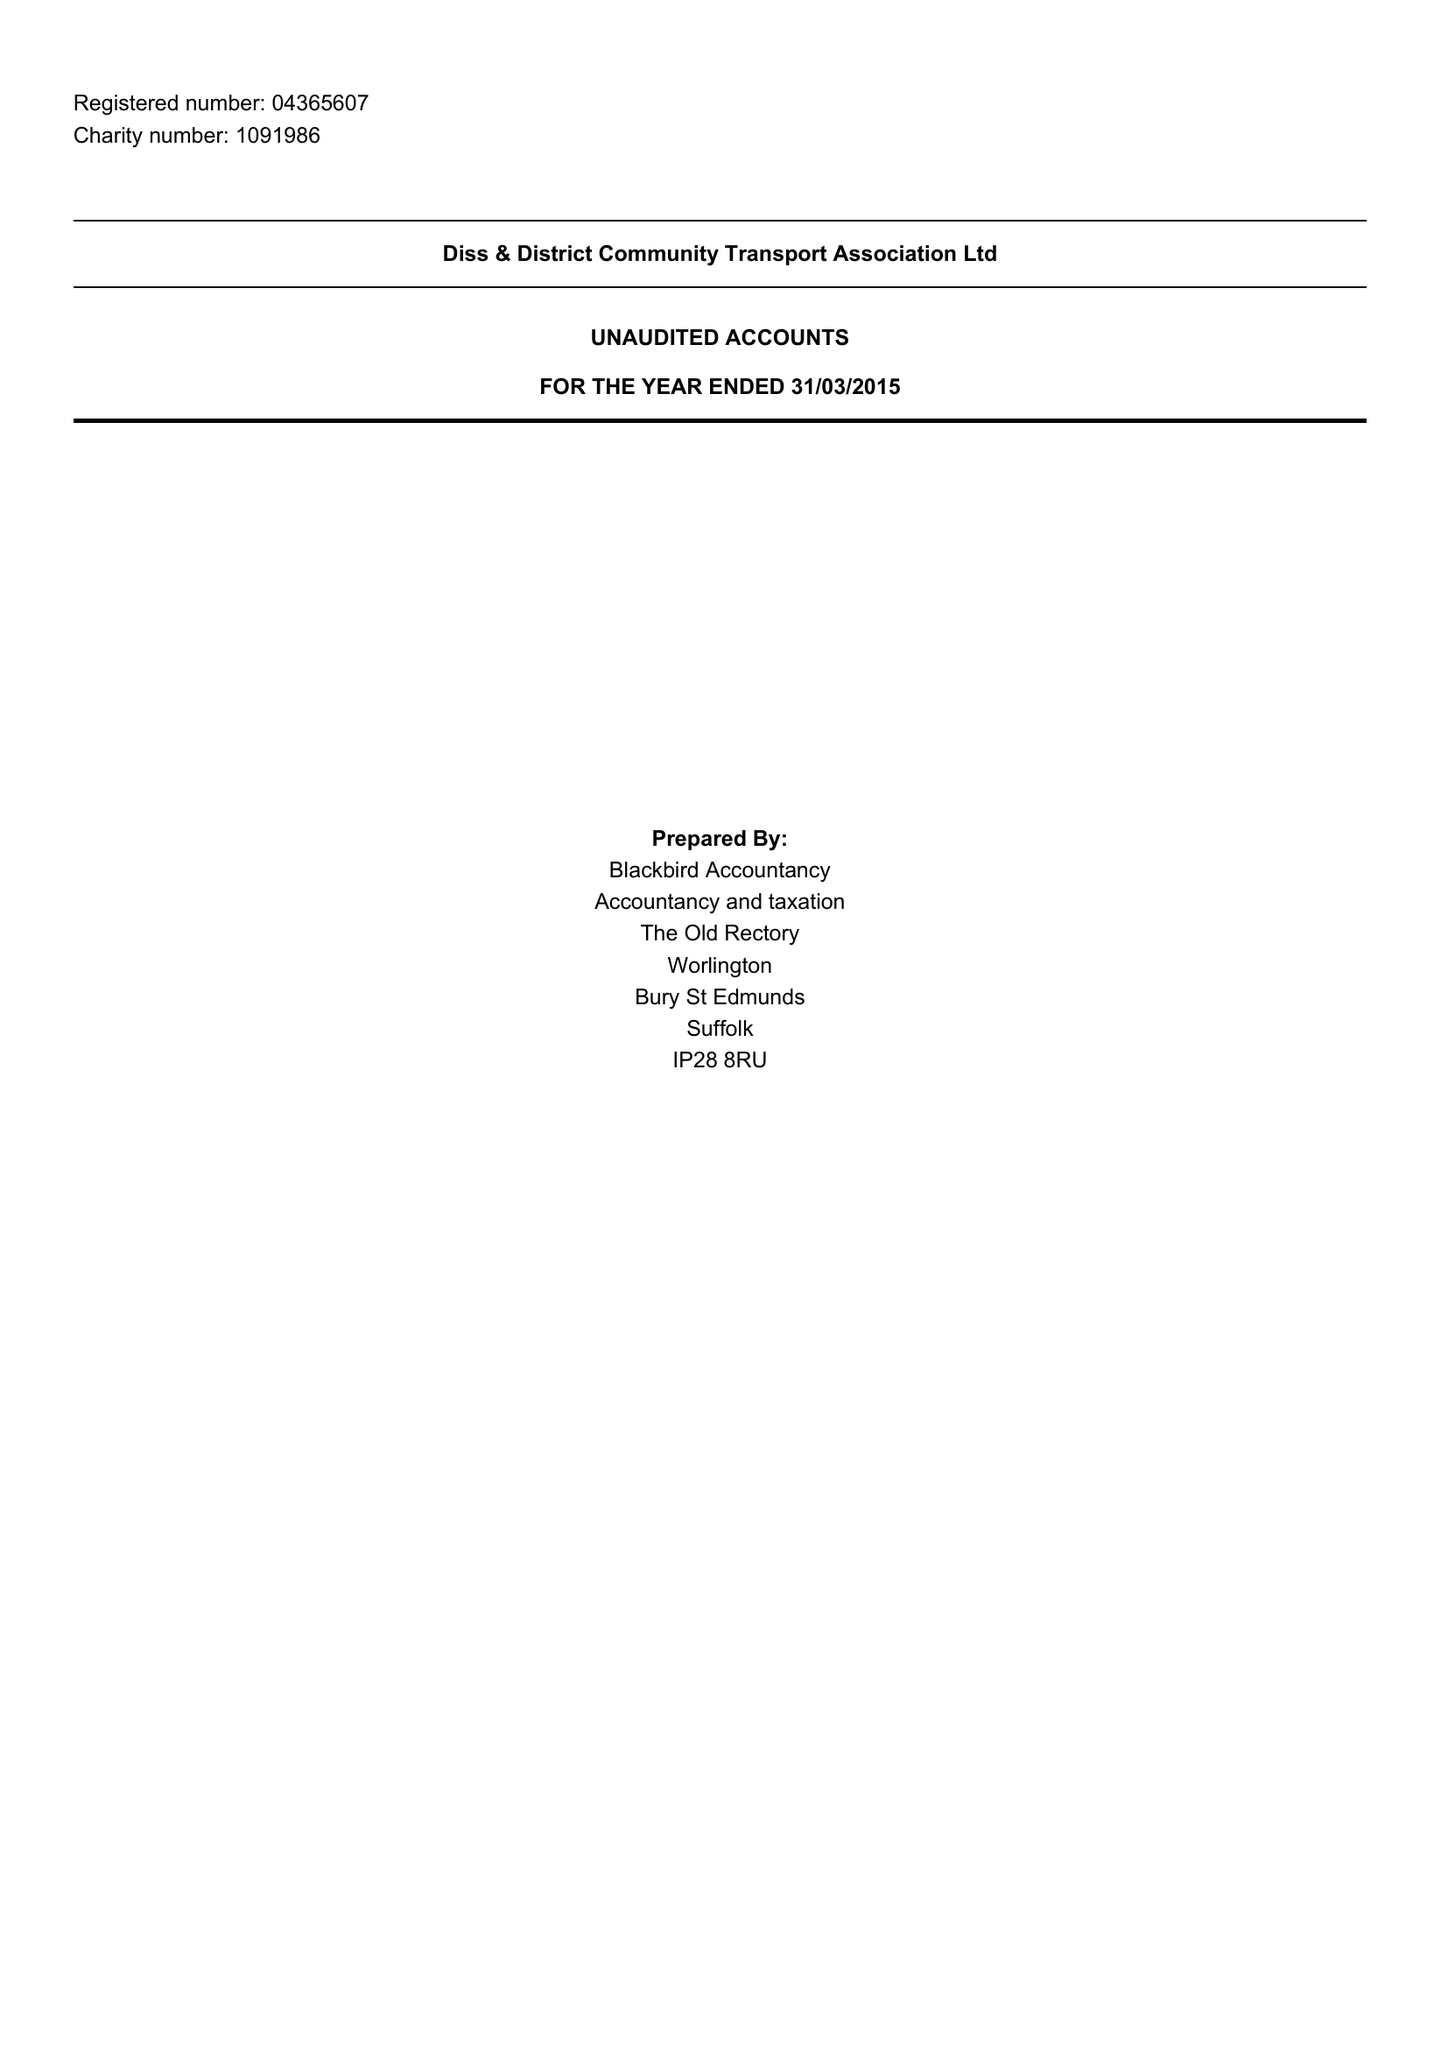What is the value for the address__street_line?
Answer the question using a single word or phrase. THE STREET 